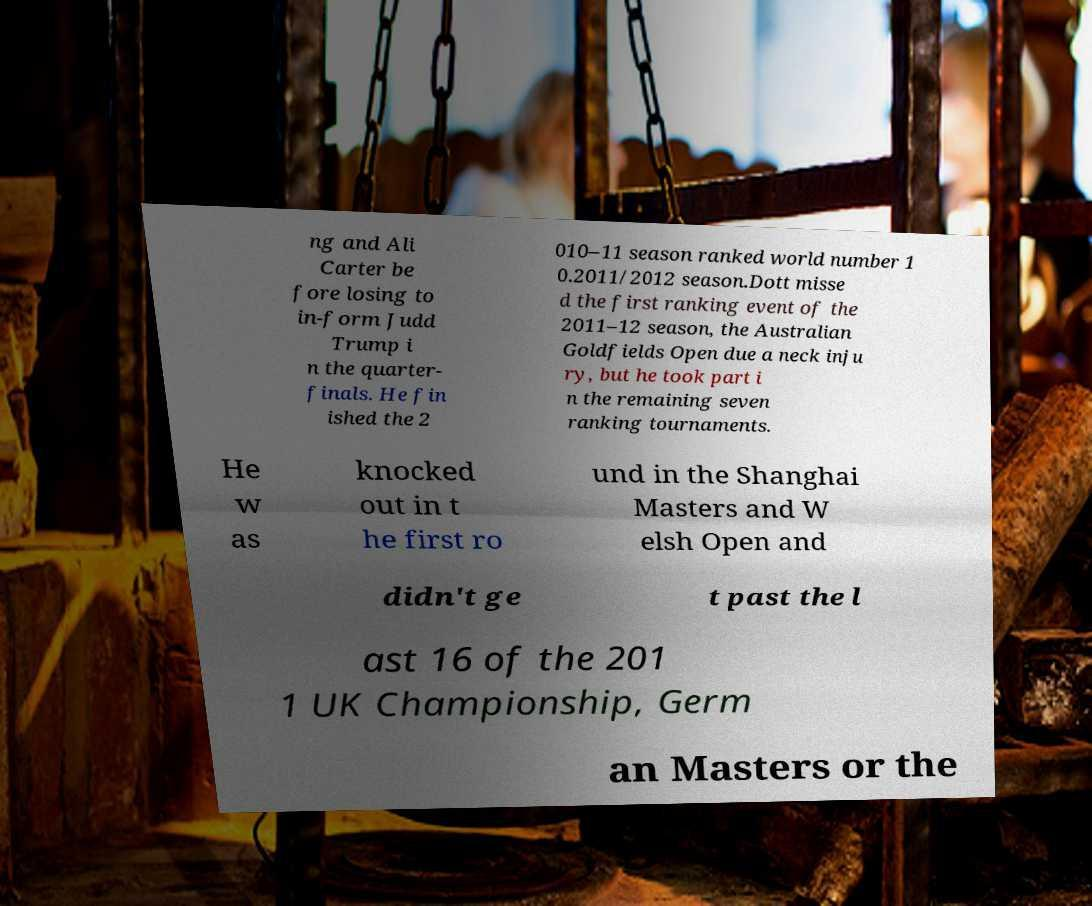What messages or text are displayed in this image? I need them in a readable, typed format. ng and Ali Carter be fore losing to in-form Judd Trump i n the quarter- finals. He fin ished the 2 010–11 season ranked world number 1 0.2011/2012 season.Dott misse d the first ranking event of the 2011–12 season, the Australian Goldfields Open due a neck inju ry, but he took part i n the remaining seven ranking tournaments. He w as knocked out in t he first ro und in the Shanghai Masters and W elsh Open and didn't ge t past the l ast 16 of the 201 1 UK Championship, Germ an Masters or the 